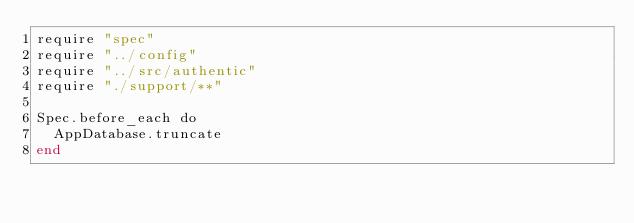Convert code to text. <code><loc_0><loc_0><loc_500><loc_500><_Crystal_>require "spec"
require "../config"
require "../src/authentic"
require "./support/**"

Spec.before_each do
  AppDatabase.truncate
end
</code> 